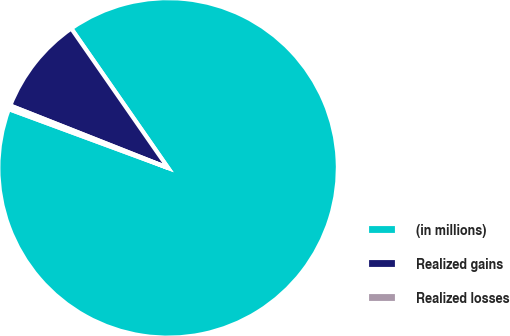<chart> <loc_0><loc_0><loc_500><loc_500><pie_chart><fcel>(in millions)<fcel>Realized gains<fcel>Realized losses<nl><fcel>90.29%<fcel>9.35%<fcel>0.36%<nl></chart> 